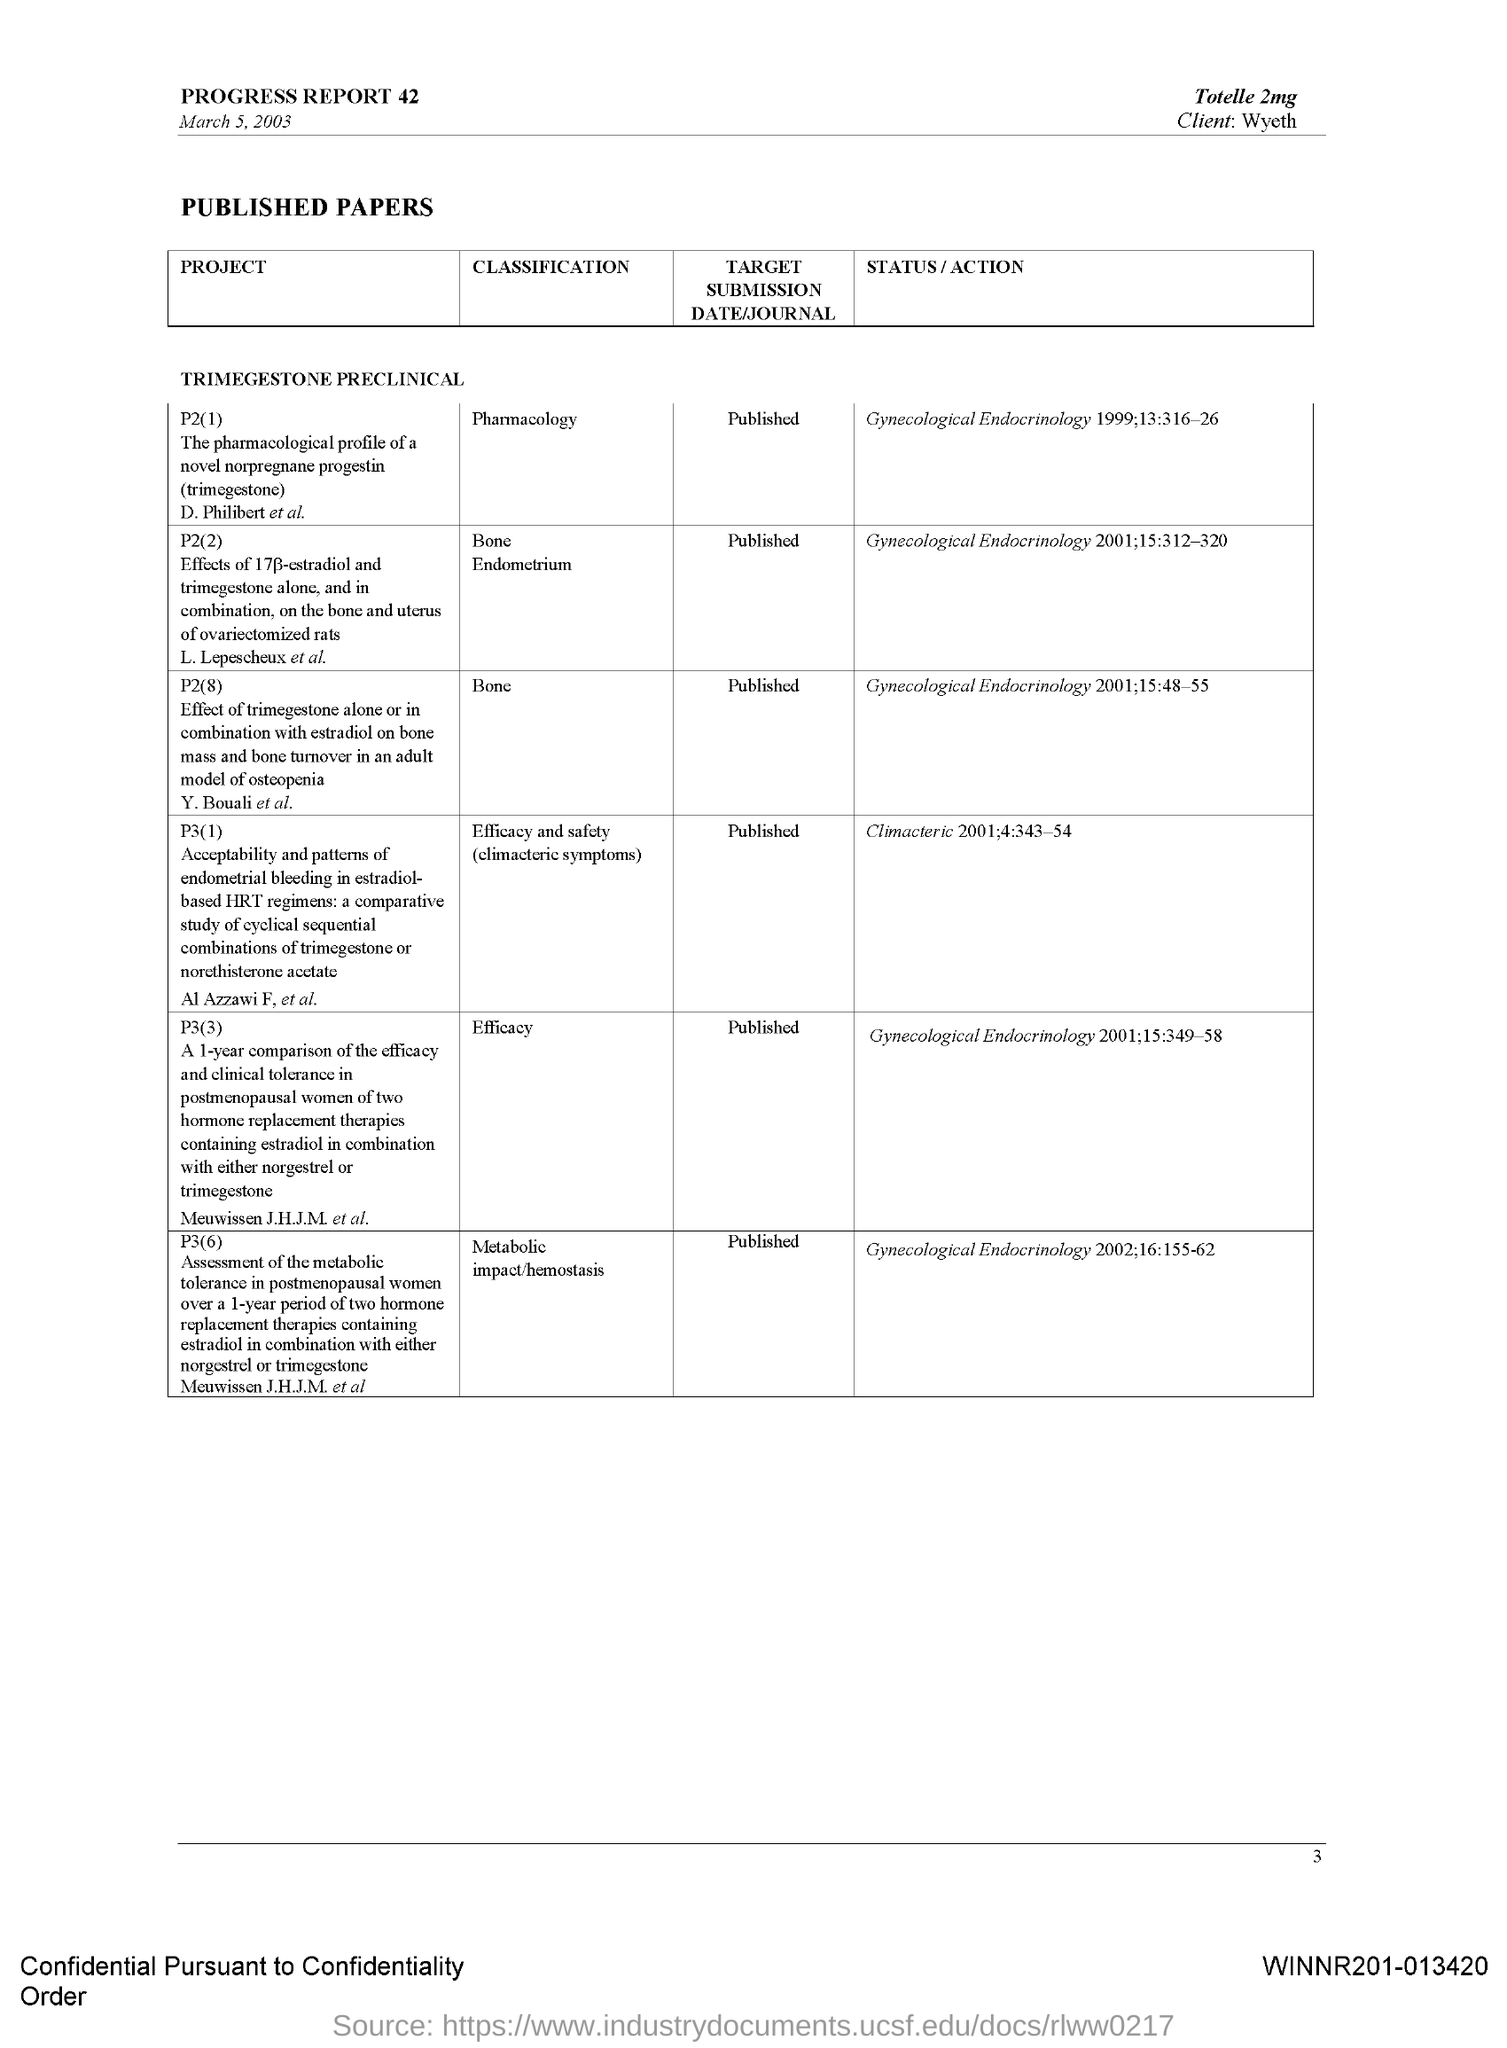Draw attention to some important aspects in this diagram. The target submission date/journal for project P3(6) has been published and it is now known. The client mentioned is Wyeth. The project P2(1) concerns the pharmacological profile of a novel norpregnane progestin called trimegestone. The progress report is dated March 5, 2003. The drug mentioned is 2mg Totelle. 